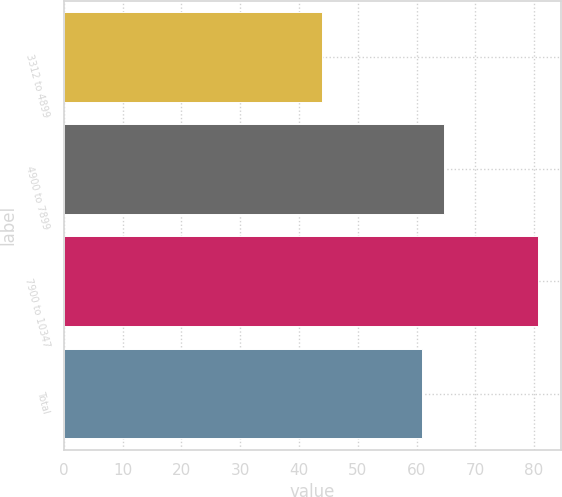<chart> <loc_0><loc_0><loc_500><loc_500><bar_chart><fcel>3312 to 4899<fcel>4900 to 7899<fcel>7900 to 10347<fcel>Total<nl><fcel>43.88<fcel>64.68<fcel>80.63<fcel>60.88<nl></chart> 